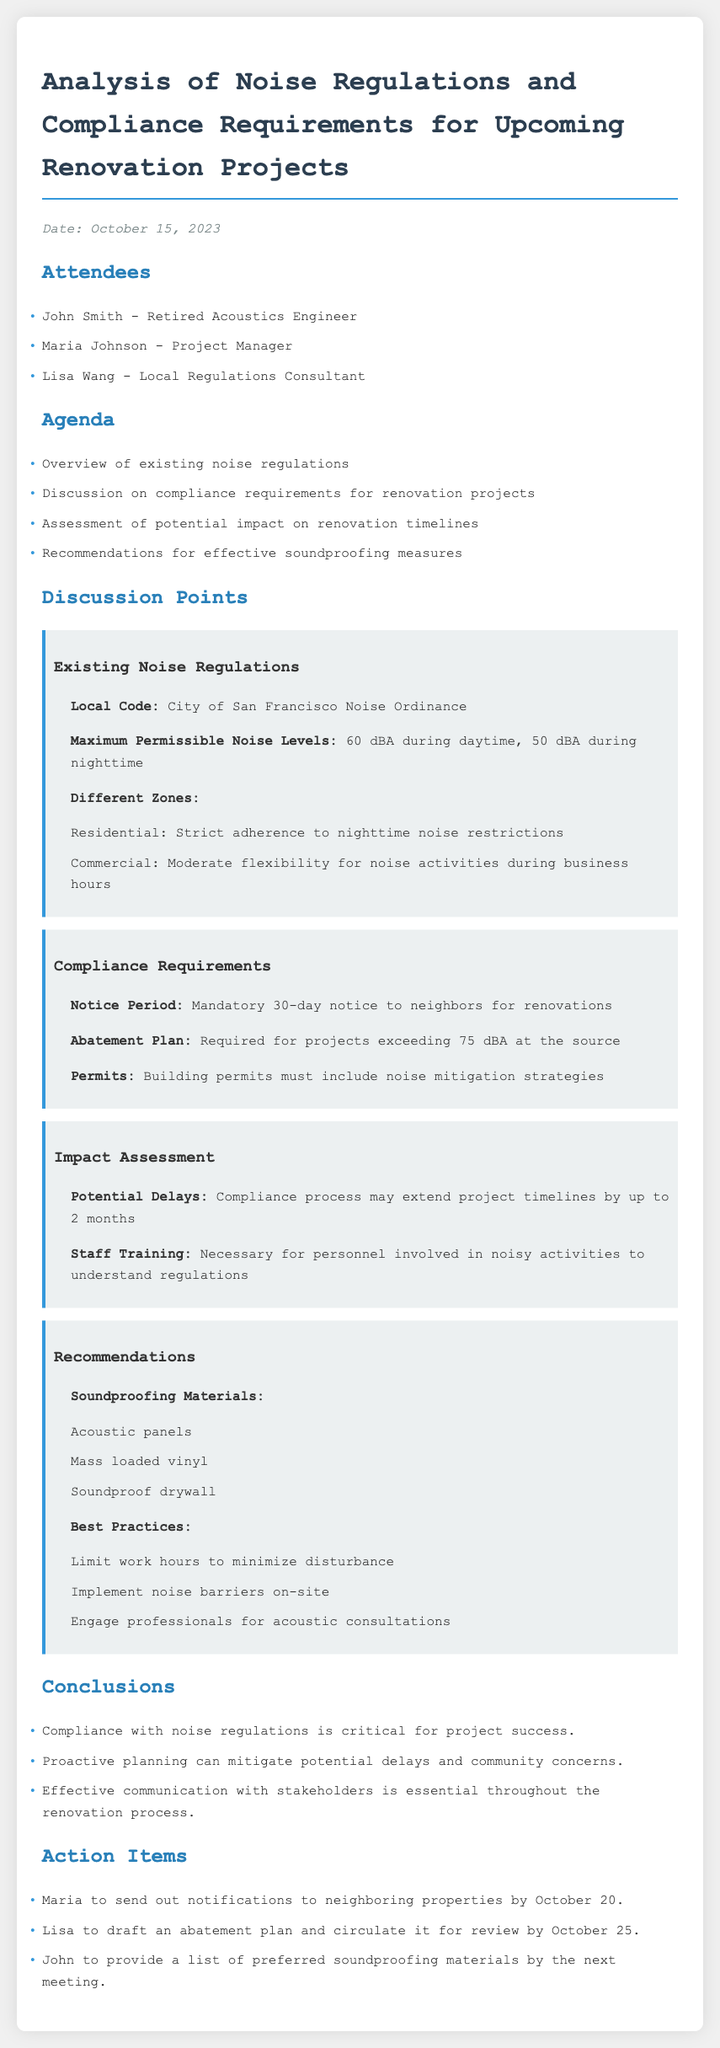what is the date of the meeting? The date of the meeting is explicitly stated at the beginning of the document.
Answer: October 15, 2023 who is the project manager? The project manager is listed among the attendees of the meeting.
Answer: Maria Johnson what are the maximum permissible noise levels during nighttime? The maximum permissible noise levels are specified in the section discussing existing noise regulations.
Answer: 50 dBA what is the notice period required for renovations? The notice period is detailed under compliance requirements.
Answer: 30-day notice how may the compliance process impact project timelines? The impact assessment mentions the possible delay due to compliance processes.
Answer: Up to 2 months which materials are recommended for soundproofing measures? The recommendations section lists specific soundproofing materials.
Answer: Acoustic panels, Mass loaded vinyl, Soundproof drywall what essential communication aspect is highlighted in the conclusions? The conclusions emphasize an important communication strategy during renovations.
Answer: Communication with stakeholders who will draft the abatement plan? The action items specify the individual responsible for drafting the abatement plan.
Answer: Lisa 